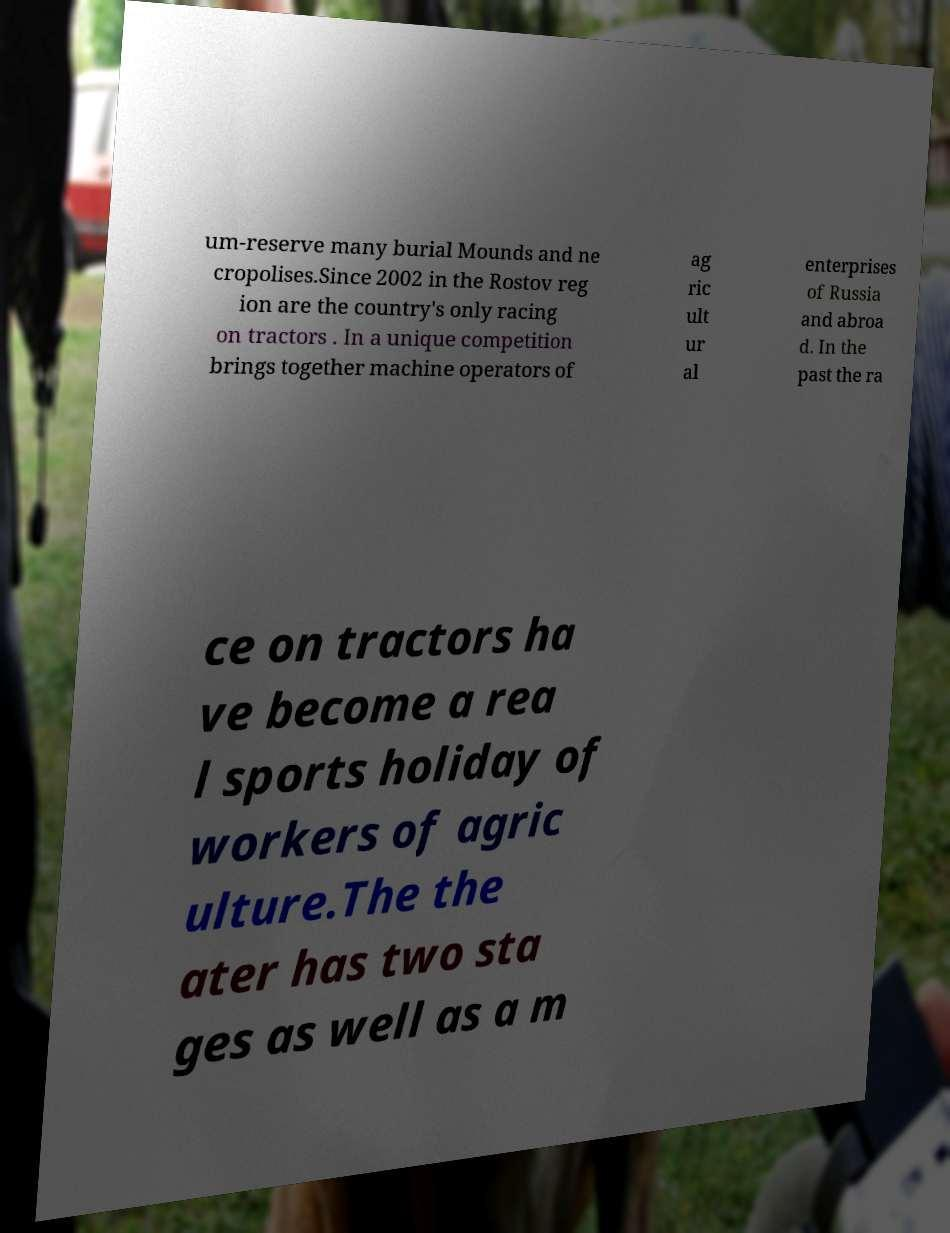There's text embedded in this image that I need extracted. Can you transcribe it verbatim? um-reserve many burial Mounds and ne cropolises.Since 2002 in the Rostov reg ion are the country's only racing on tractors . In a unique competition brings together machine operators of ag ric ult ur al enterprises of Russia and abroa d. In the past the ra ce on tractors ha ve become a rea l sports holiday of workers of agric ulture.The the ater has two sta ges as well as a m 